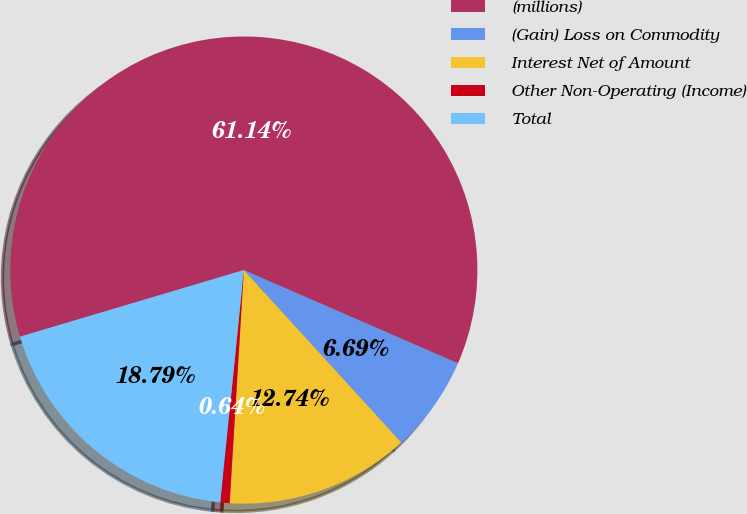<chart> <loc_0><loc_0><loc_500><loc_500><pie_chart><fcel>(millions)<fcel>(Gain) Loss on Commodity<fcel>Interest Net of Amount<fcel>Other Non-Operating (Income)<fcel>Total<nl><fcel>61.14%<fcel>6.69%<fcel>12.74%<fcel>0.64%<fcel>18.79%<nl></chart> 